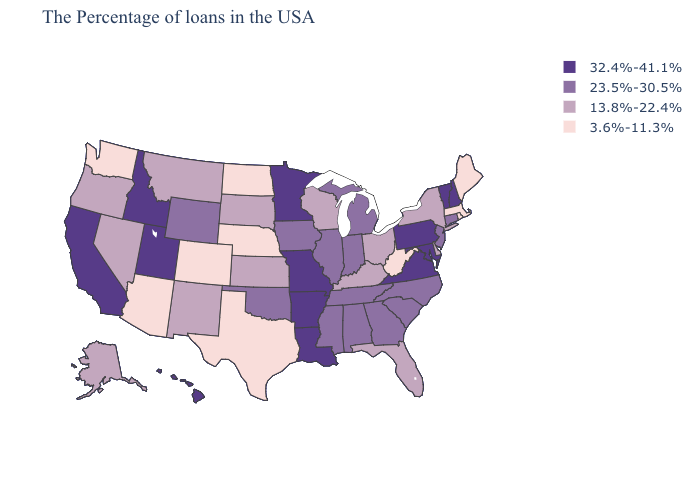Among the states that border Montana , does Wyoming have the highest value?
Be succinct. No. Does Idaho have the highest value in the USA?
Short answer required. Yes. Does Alabama have a higher value than Virginia?
Quick response, please. No. Does West Virginia have the same value as Oregon?
Answer briefly. No. Among the states that border North Carolina , does Virginia have the lowest value?
Be succinct. No. Name the states that have a value in the range 3.6%-11.3%?
Quick response, please. Maine, Massachusetts, Rhode Island, West Virginia, Nebraska, Texas, North Dakota, Colorado, Arizona, Washington. Name the states that have a value in the range 32.4%-41.1%?
Be succinct. New Hampshire, Vermont, Maryland, Pennsylvania, Virginia, Louisiana, Missouri, Arkansas, Minnesota, Utah, Idaho, California, Hawaii. Among the states that border Louisiana , which have the highest value?
Quick response, please. Arkansas. Name the states that have a value in the range 23.5%-30.5%?
Be succinct. Connecticut, New Jersey, North Carolina, South Carolina, Georgia, Michigan, Indiana, Alabama, Tennessee, Illinois, Mississippi, Iowa, Oklahoma, Wyoming. Name the states that have a value in the range 13.8%-22.4%?
Write a very short answer. New York, Delaware, Ohio, Florida, Kentucky, Wisconsin, Kansas, South Dakota, New Mexico, Montana, Nevada, Oregon, Alaska. Name the states that have a value in the range 3.6%-11.3%?
Quick response, please. Maine, Massachusetts, Rhode Island, West Virginia, Nebraska, Texas, North Dakota, Colorado, Arizona, Washington. Which states have the lowest value in the USA?
Short answer required. Maine, Massachusetts, Rhode Island, West Virginia, Nebraska, Texas, North Dakota, Colorado, Arizona, Washington. What is the value of Alaska?
Be succinct. 13.8%-22.4%. Name the states that have a value in the range 32.4%-41.1%?
Write a very short answer. New Hampshire, Vermont, Maryland, Pennsylvania, Virginia, Louisiana, Missouri, Arkansas, Minnesota, Utah, Idaho, California, Hawaii. Which states have the lowest value in the West?
Short answer required. Colorado, Arizona, Washington. 